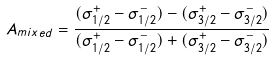<formula> <loc_0><loc_0><loc_500><loc_500>A _ { m i x e d } = \frac { ( \sigma _ { 1 / 2 } ^ { + } - \sigma _ { 1 / 2 } ^ { - } ) - ( \sigma _ { 3 / 2 } ^ { + } - \sigma _ { 3 / 2 } ^ { - } ) } { ( \sigma _ { 1 / 2 } ^ { + } - \sigma _ { 1 / 2 } ^ { - } ) + ( \sigma _ { 3 / 2 } ^ { + } - \sigma _ { 3 / 2 } ^ { - } ) }</formula> 